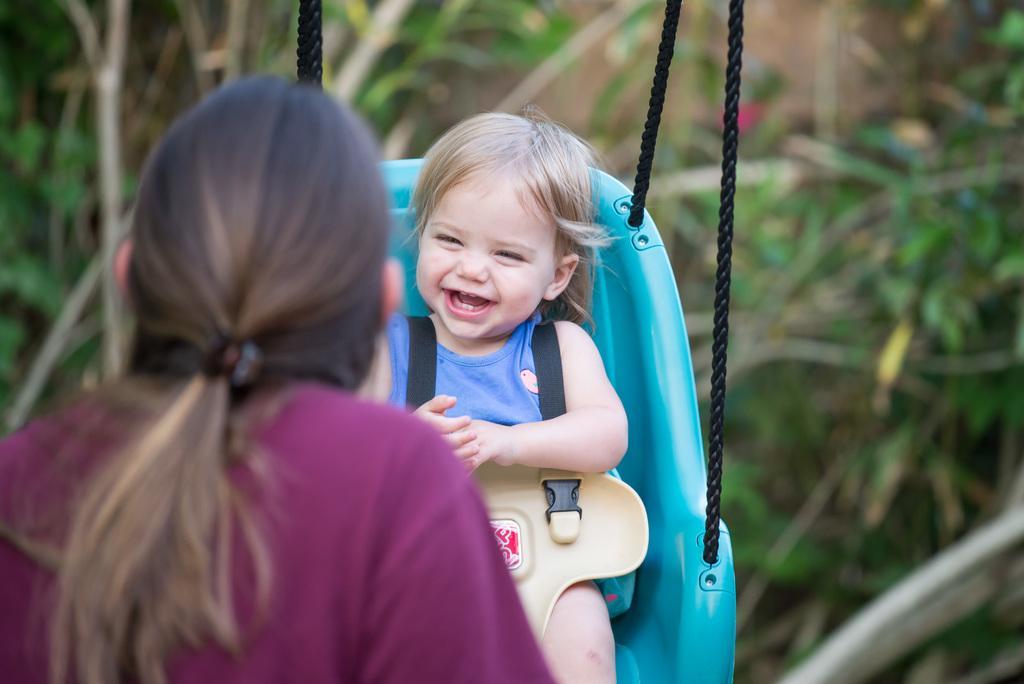Please provide a concise description of this image. In this picture we can see a kid is sitting on the swing. In front of the kid there is a woman and behind the kid there are some blurred plants. 